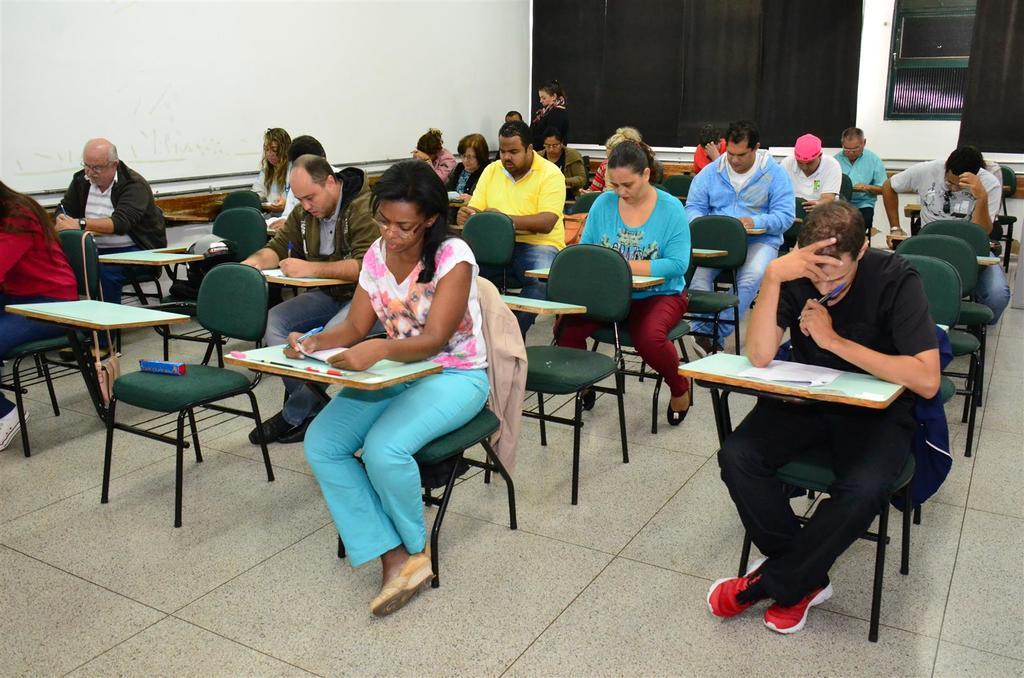In one or two sentences, can you explain what this image depicts? A group of people are writing an examination in a room. 